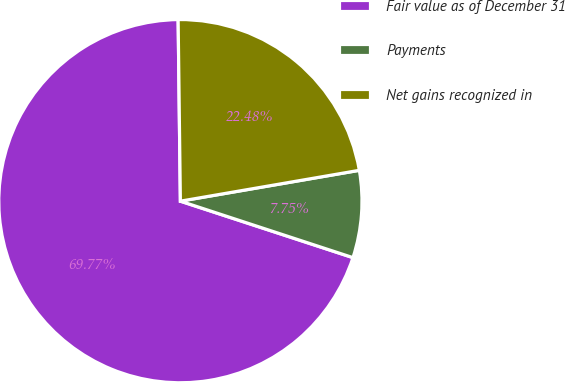<chart> <loc_0><loc_0><loc_500><loc_500><pie_chart><fcel>Fair value as of December 31<fcel>Payments<fcel>Net gains recognized in<nl><fcel>69.77%<fcel>7.75%<fcel>22.48%<nl></chart> 